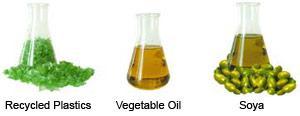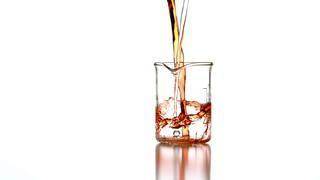The first image is the image on the left, the second image is the image on the right. For the images displayed, is the sentence "There are substances in three containers in the image on the left." factually correct? Answer yes or no. Yes. 